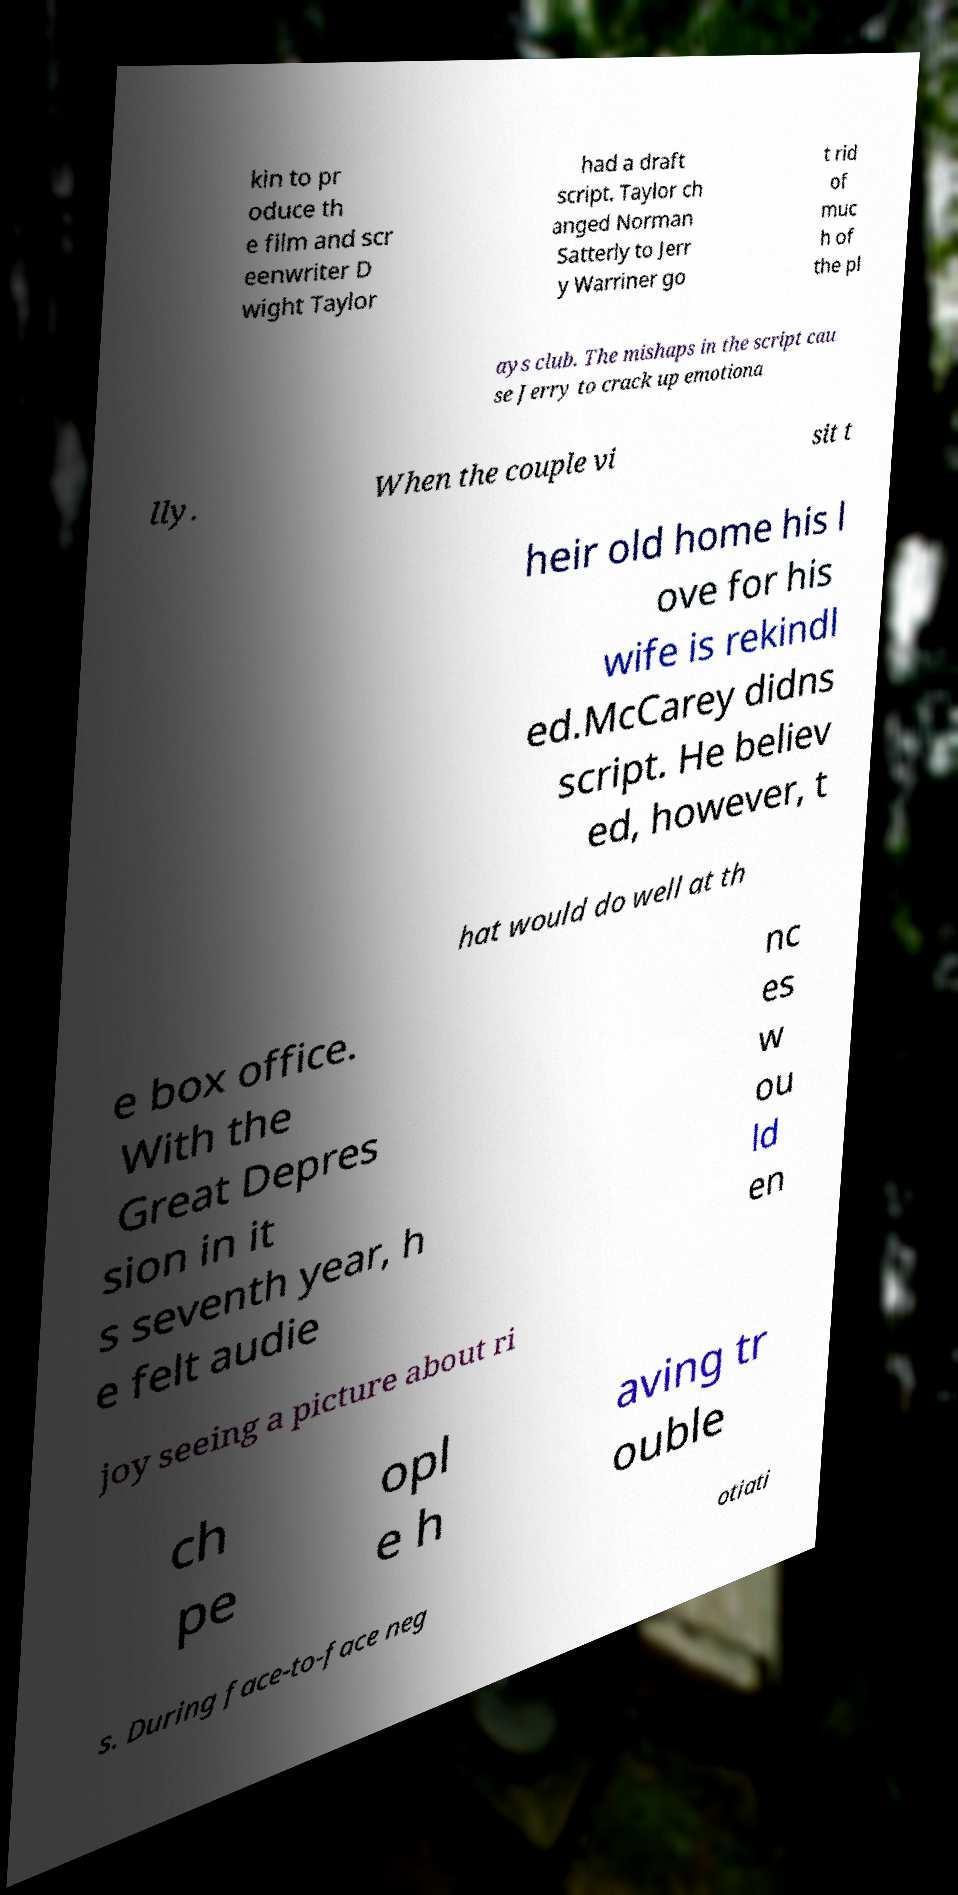Can you accurately transcribe the text from the provided image for me? kin to pr oduce th e film and scr eenwriter D wight Taylor had a draft script. Taylor ch anged Norman Satterly to Jerr y Warriner go t rid of muc h of the pl ays club. The mishaps in the script cau se Jerry to crack up emotiona lly. When the couple vi sit t heir old home his l ove for his wife is rekindl ed.McCarey didns script. He believ ed, however, t hat would do well at th e box office. With the Great Depres sion in it s seventh year, h e felt audie nc es w ou ld en joy seeing a picture about ri ch pe opl e h aving tr ouble s. During face-to-face neg otiati 